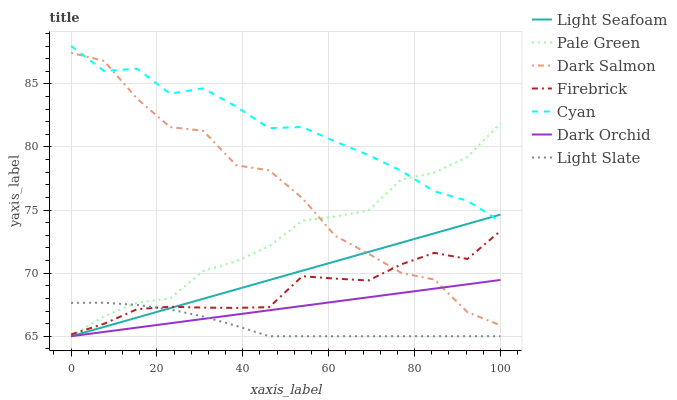Does Firebrick have the minimum area under the curve?
Answer yes or no. No. Does Firebrick have the maximum area under the curve?
Answer yes or no. No. Is Firebrick the smoothest?
Answer yes or no. No. Is Firebrick the roughest?
Answer yes or no. No. Does Firebrick have the lowest value?
Answer yes or no. No. Does Firebrick have the highest value?
Answer yes or no. No. Is Light Slate less than Dark Salmon?
Answer yes or no. Yes. Is Cyan greater than Firebrick?
Answer yes or no. Yes. Does Light Slate intersect Dark Salmon?
Answer yes or no. No. 